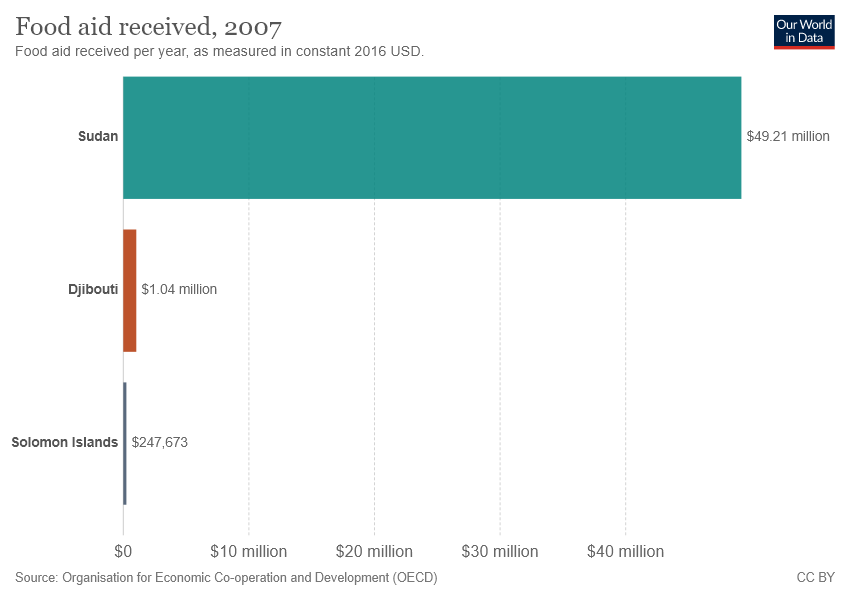Draw attention to some important aspects in this diagram. The total value of the largest two bars is 50.25. The value of the largest bar is 49.21. 